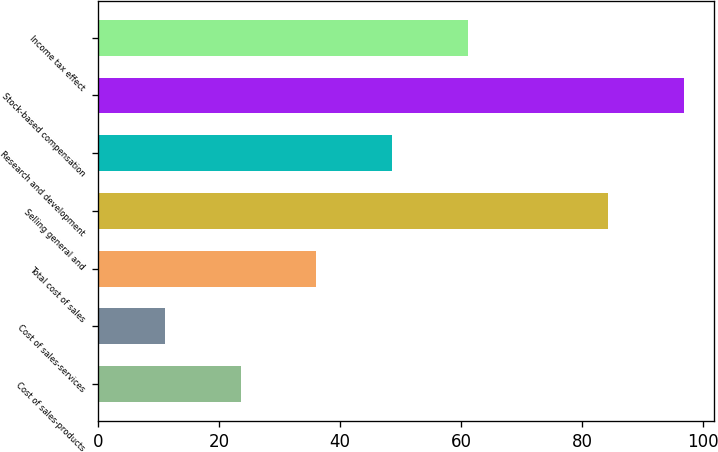<chart> <loc_0><loc_0><loc_500><loc_500><bar_chart><fcel>Cost of sales-products<fcel>Cost of sales-services<fcel>Total cost of sales<fcel>Selling general and<fcel>Research and development<fcel>Stock-based compensation<fcel>Income tax effect<nl><fcel>23.54<fcel>11<fcel>36.08<fcel>84.3<fcel>48.62<fcel>96.84<fcel>61.16<nl></chart> 